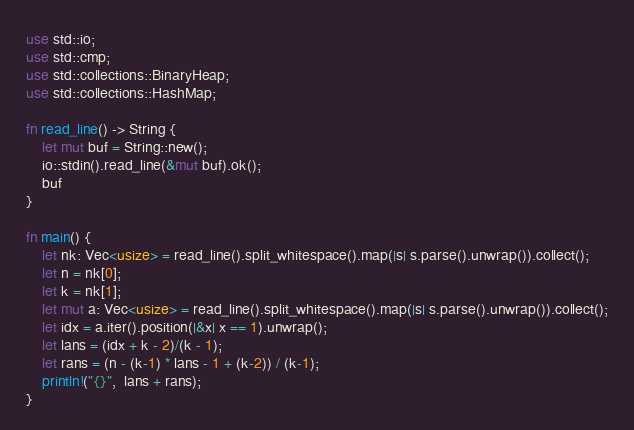Convert code to text. <code><loc_0><loc_0><loc_500><loc_500><_Rust_>use std::io;
use std::cmp;
use std::collections::BinaryHeap;
use std::collections::HashMap;

fn read_line() -> String {
    let mut buf = String::new();
    io::stdin().read_line(&mut buf).ok();
    buf
}

fn main() {
    let nk: Vec<usize> = read_line().split_whitespace().map(|s| s.parse().unwrap()).collect();
    let n = nk[0];
    let k = nk[1];
    let mut a: Vec<usize> = read_line().split_whitespace().map(|s| s.parse().unwrap()).collect();
    let idx = a.iter().position(|&x| x == 1).unwrap();
    let lans = (idx + k - 2)/(k - 1);
    let rans = (n - (k-1) * lans - 1 + (k-2)) / (k-1);
    println!("{}",  lans + rans);
}
</code> 